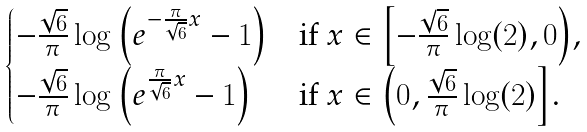Convert formula to latex. <formula><loc_0><loc_0><loc_500><loc_500>\begin{cases} - \frac { \sqrt { 6 } } { \pi } \log \left ( e ^ { - \frac { \pi } { \sqrt { 6 } } x } - 1 \right ) & \text {if $x \in \left[-\frac{\sqrt{6}}{\pi}\log(2),0 \right)$,} \\ - \frac { \sqrt { 6 } } { \pi } \log \left ( e ^ { \frac { \pi } { \sqrt { 6 } } x } - 1 \right ) & \text {if $x \in \left(0,\frac{\sqrt{6}}{\pi}\log(2) \right]$.} \end{cases}</formula> 